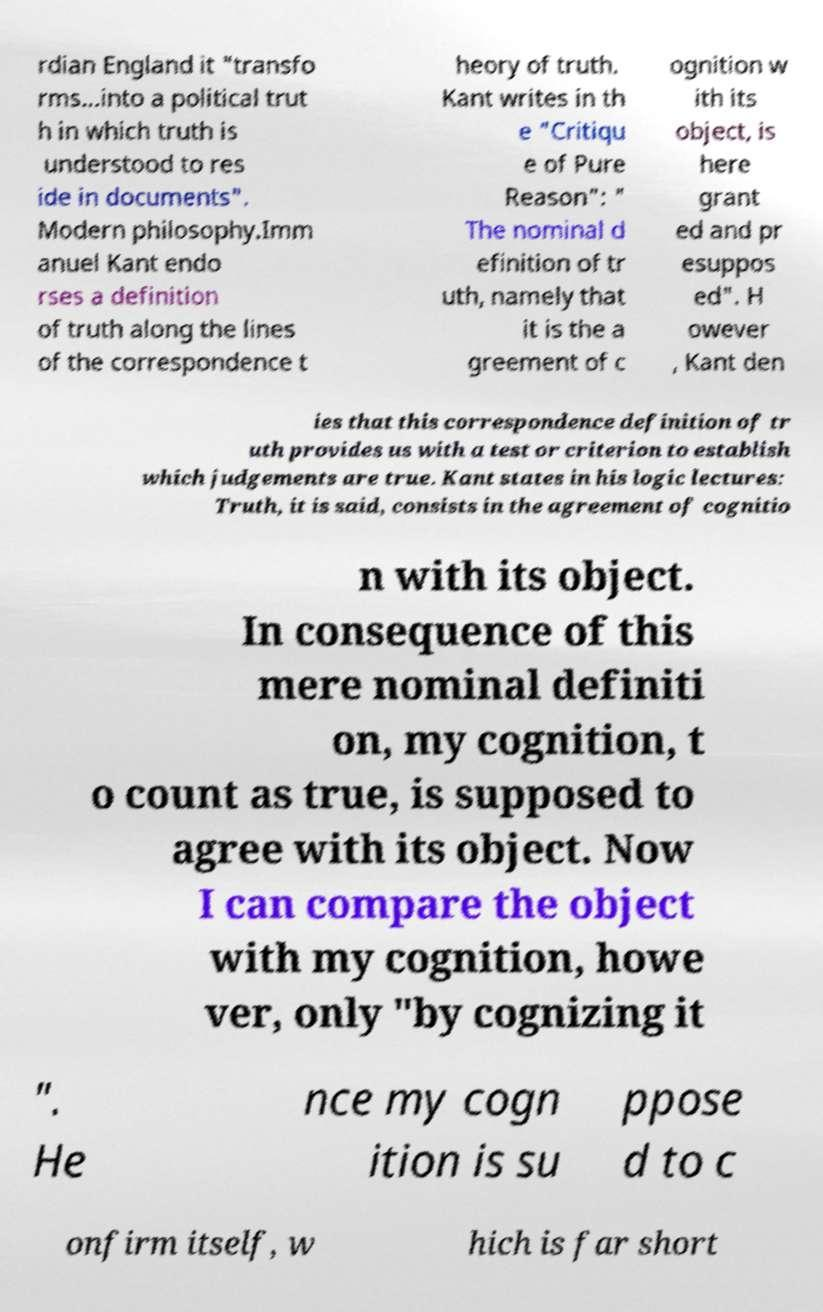Please identify and transcribe the text found in this image. rdian England it "transfo rms...into a political trut h in which truth is understood to res ide in documents". Modern philosophy.Imm anuel Kant endo rses a definition of truth along the lines of the correspondence t heory of truth. Kant writes in th e "Critiqu e of Pure Reason": " The nominal d efinition of tr uth, namely that it is the a greement of c ognition w ith its object, is here grant ed and pr esuppos ed". H owever , Kant den ies that this correspondence definition of tr uth provides us with a test or criterion to establish which judgements are true. Kant states in his logic lectures: Truth, it is said, consists in the agreement of cognitio n with its object. In consequence of this mere nominal definiti on, my cognition, t o count as true, is supposed to agree with its object. Now I can compare the object with my cognition, howe ver, only "by cognizing it ". He nce my cogn ition is su ppose d to c onfirm itself, w hich is far short 